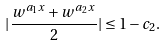Convert formula to latex. <formula><loc_0><loc_0><loc_500><loc_500>| \frac { w ^ { a _ { 1 } x } + w ^ { a _ { 2 } x } } { 2 } | \leq 1 - c _ { 2 } .</formula> 